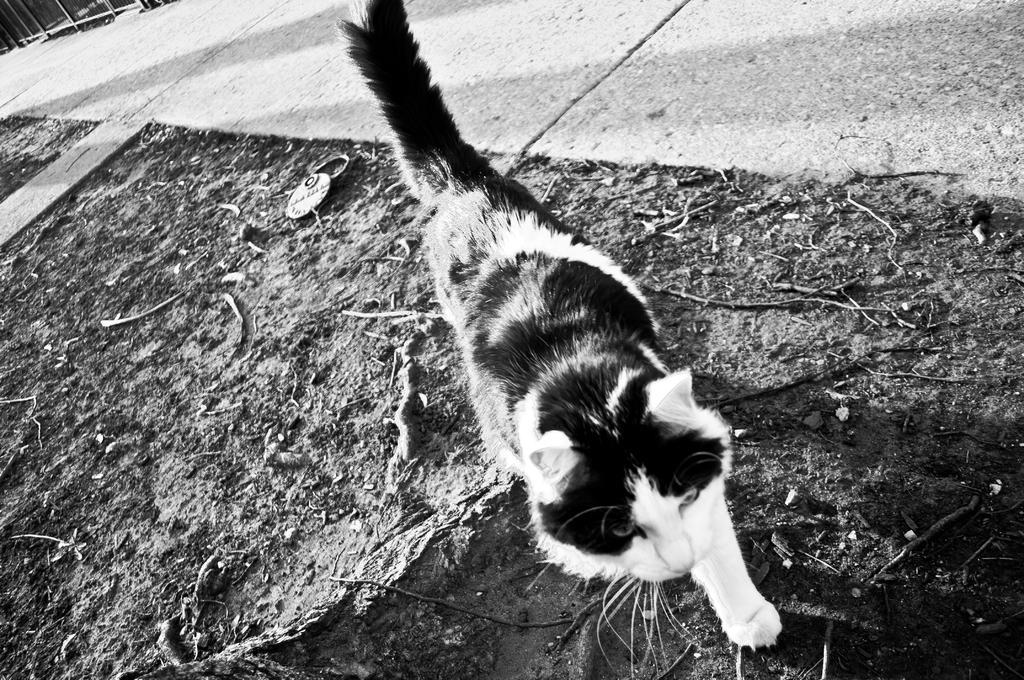Please provide a concise description of this image. In the image there is a cat walking on the side of the footpath, this is a black and white picture. 